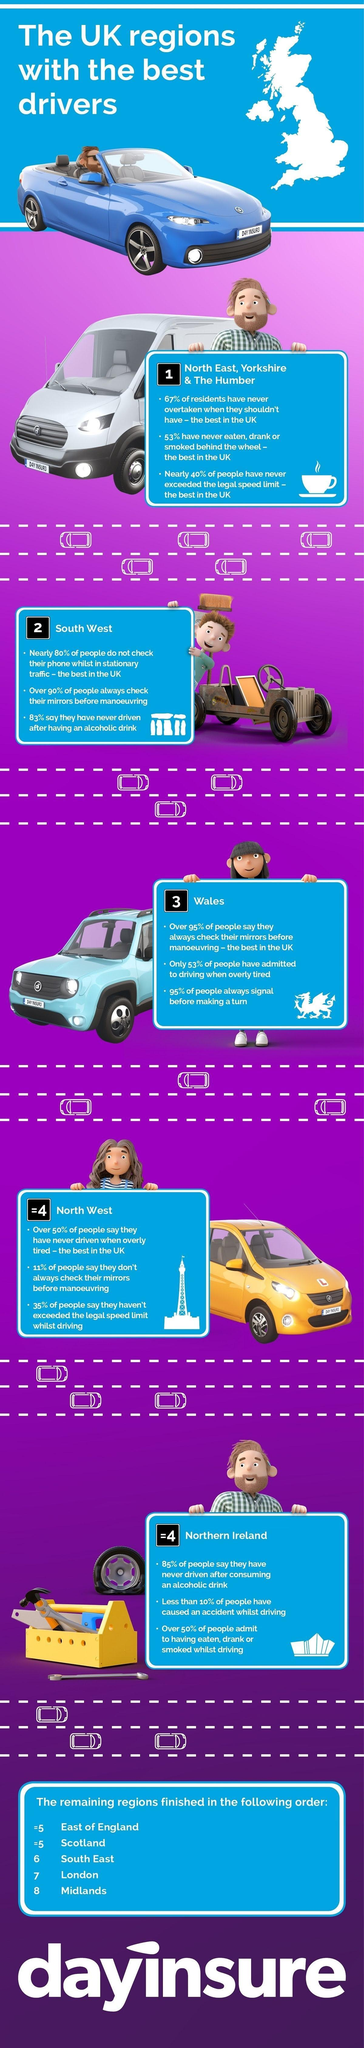Which region is the best in UK for never exceeding the legal speed limit ?
Answer the question with a short phrase. North East, Yorkshire & The Humber Which region is represented by the image of a tool box ? Northern Ireland Among the eight regions, which three regions were ranked last ? South East, London, Midlands Which UK region stands second best with regards to best drivers ? South west In which region do 95% of a drivers signal while making a turn ? Wales What is the colour of the car representing the North west region -  blue, white, yellow or red ? Yellow In total how many UK regions have been ranked here ? 8 In South west what percent of people do not check their mirrors before manoeuvering ? 10% In which region, do 80% of the drivers not check their phones while in stationary traffic ? South west 